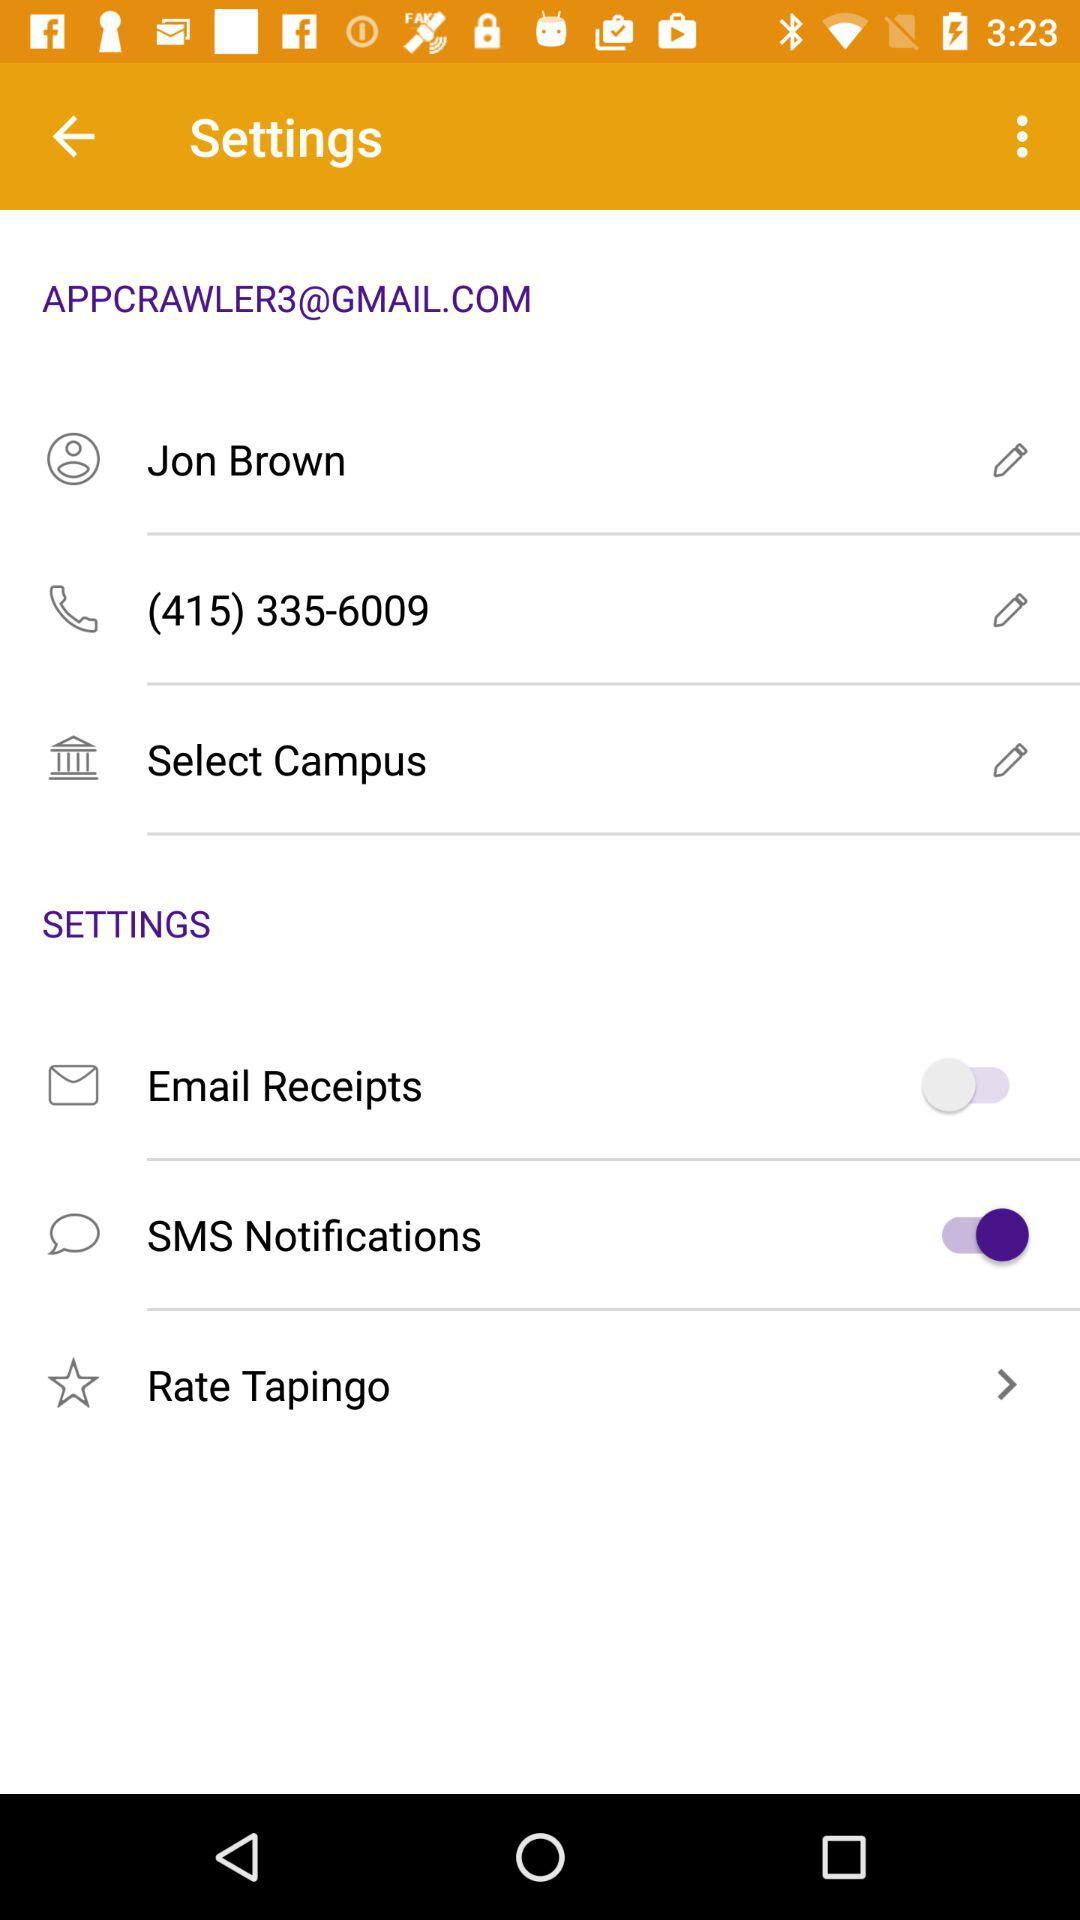What is the name of the user? The name of the user is Jon Brown. 